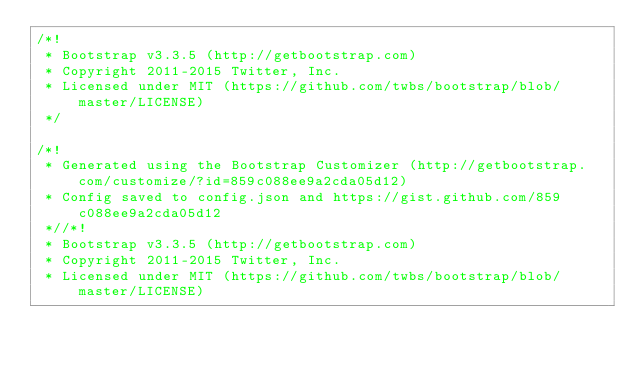<code> <loc_0><loc_0><loc_500><loc_500><_CSS_>/*!
 * Bootstrap v3.3.5 (http://getbootstrap.com)
 * Copyright 2011-2015 Twitter, Inc.
 * Licensed under MIT (https://github.com/twbs/bootstrap/blob/master/LICENSE)
 */

/*!
 * Generated using the Bootstrap Customizer (http://getbootstrap.com/customize/?id=859c088ee9a2cda05d12)
 * Config saved to config.json and https://gist.github.com/859c088ee9a2cda05d12
 *//*!
 * Bootstrap v3.3.5 (http://getbootstrap.com)
 * Copyright 2011-2015 Twitter, Inc.
 * Licensed under MIT (https://github.com/twbs/bootstrap/blob/master/LICENSE)</code> 